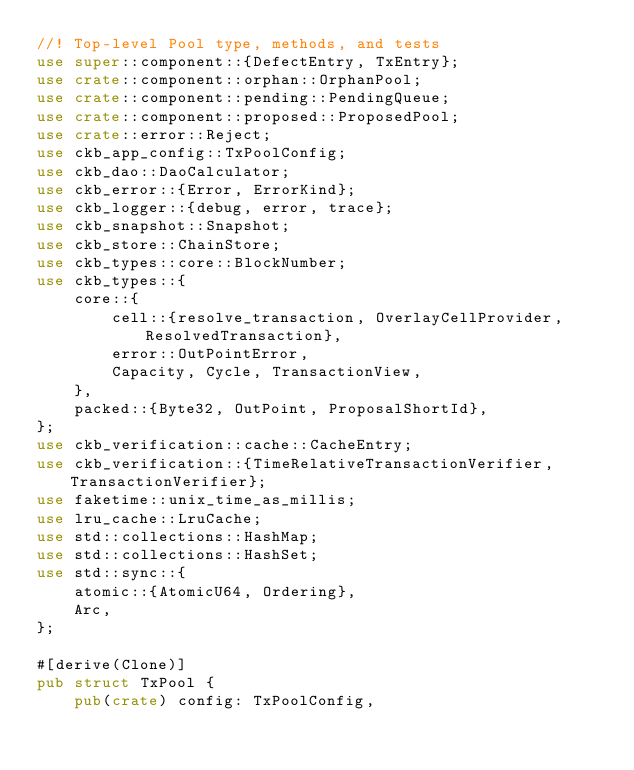Convert code to text. <code><loc_0><loc_0><loc_500><loc_500><_Rust_>//! Top-level Pool type, methods, and tests
use super::component::{DefectEntry, TxEntry};
use crate::component::orphan::OrphanPool;
use crate::component::pending::PendingQueue;
use crate::component::proposed::ProposedPool;
use crate::error::Reject;
use ckb_app_config::TxPoolConfig;
use ckb_dao::DaoCalculator;
use ckb_error::{Error, ErrorKind};
use ckb_logger::{debug, error, trace};
use ckb_snapshot::Snapshot;
use ckb_store::ChainStore;
use ckb_types::core::BlockNumber;
use ckb_types::{
    core::{
        cell::{resolve_transaction, OverlayCellProvider, ResolvedTransaction},
        error::OutPointError,
        Capacity, Cycle, TransactionView,
    },
    packed::{Byte32, OutPoint, ProposalShortId},
};
use ckb_verification::cache::CacheEntry;
use ckb_verification::{TimeRelativeTransactionVerifier, TransactionVerifier};
use faketime::unix_time_as_millis;
use lru_cache::LruCache;
use std::collections::HashMap;
use std::collections::HashSet;
use std::sync::{
    atomic::{AtomicU64, Ordering},
    Arc,
};

#[derive(Clone)]
pub struct TxPool {
    pub(crate) config: TxPoolConfig,</code> 